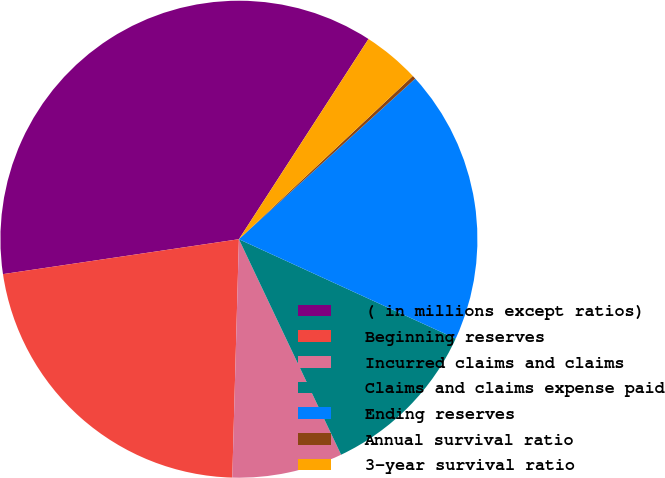Convert chart. <chart><loc_0><loc_0><loc_500><loc_500><pie_chart><fcel>( in millions except ratios)<fcel>Beginning reserves<fcel>Incurred claims and claims<fcel>Claims and claims expense paid<fcel>Ending reserves<fcel>Annual survival ratio<fcel>3-year survival ratio<nl><fcel>36.48%<fcel>22.22%<fcel>7.49%<fcel>11.11%<fcel>18.6%<fcel>0.24%<fcel>3.86%<nl></chart> 